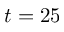<formula> <loc_0><loc_0><loc_500><loc_500>t = 2 5</formula> 